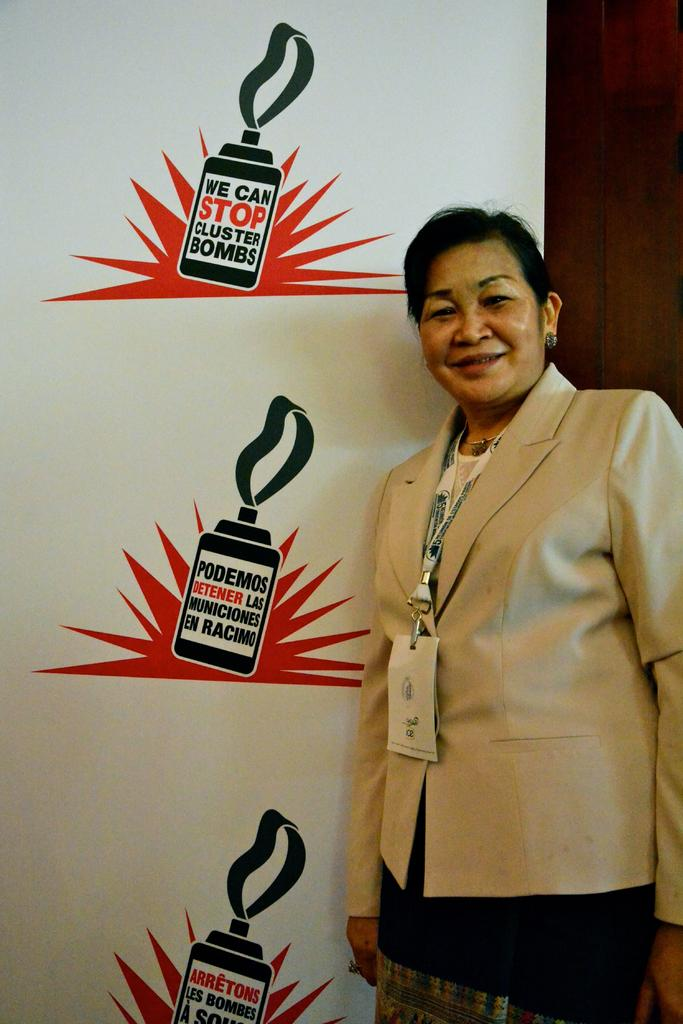Who is present in the image? There is a woman in the image. What is the woman doing in the image? The woman is standing and smiling. What can be seen in the background of the image? There is a board with text and a wooden wall in the background. What type of tin can be seen in the woman's hand in the image? There is no tin present in the image. What request is the woman making in the image? The image does not show the woman making any request. 